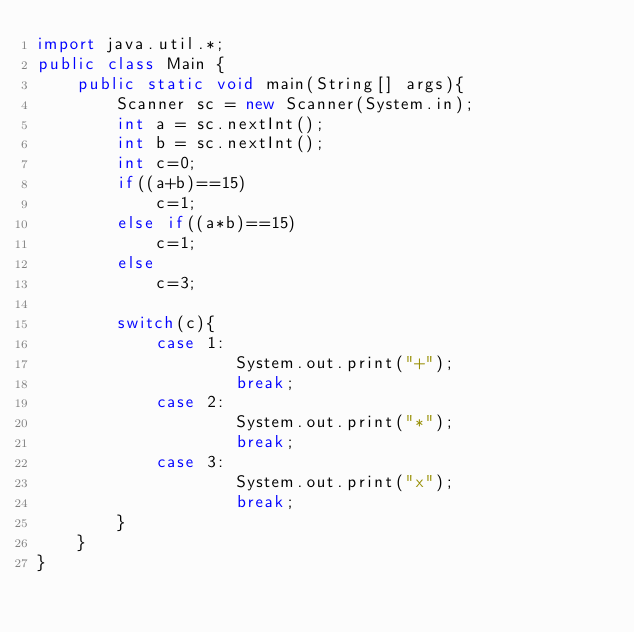Convert code to text. <code><loc_0><loc_0><loc_500><loc_500><_Java_>import java.util.*;
public class Main {
	public static void main(String[] args){
		Scanner sc = new Scanner(System.in);
		int a = sc.nextInt();
	    int b = sc.nextInt();
		int c=0;
		if((a+b)==15)
			c=1;
		else if((a*b)==15)
			c=1;
		else
			c=3;
		
		switch(c){
			case 1:
					System.out.print("+");	
					break;
			case 2:
					System.out.print("*");	
					break;
			case 3:
					System.out.print("x");	
					break;
		}
	}
}</code> 